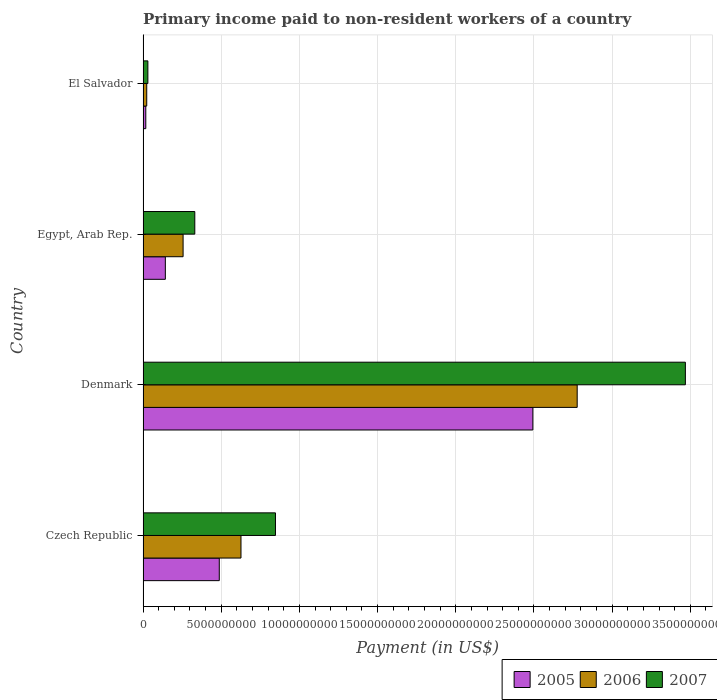How many different coloured bars are there?
Your answer should be very brief. 3. How many bars are there on the 1st tick from the bottom?
Ensure brevity in your answer.  3. What is the label of the 1st group of bars from the top?
Make the answer very short. El Salvador. In how many cases, is the number of bars for a given country not equal to the number of legend labels?
Keep it short and to the point. 0. What is the amount paid to workers in 2005 in El Salvador?
Give a very brief answer. 1.75e+08. Across all countries, what is the maximum amount paid to workers in 2007?
Provide a short and direct response. 3.47e+1. Across all countries, what is the minimum amount paid to workers in 2006?
Your answer should be compact. 2.34e+08. In which country was the amount paid to workers in 2005 maximum?
Ensure brevity in your answer.  Denmark. In which country was the amount paid to workers in 2005 minimum?
Offer a very short reply. El Salvador. What is the total amount paid to workers in 2005 in the graph?
Provide a succinct answer. 3.14e+1. What is the difference between the amount paid to workers in 2005 in Czech Republic and that in Denmark?
Offer a terse response. -2.01e+1. What is the difference between the amount paid to workers in 2005 in El Salvador and the amount paid to workers in 2006 in Czech Republic?
Your response must be concise. -6.09e+09. What is the average amount paid to workers in 2006 per country?
Ensure brevity in your answer.  9.21e+09. What is the difference between the amount paid to workers in 2006 and amount paid to workers in 2007 in El Salvador?
Provide a succinct answer. -7.36e+07. What is the ratio of the amount paid to workers in 2005 in Czech Republic to that in El Salvador?
Provide a succinct answer. 27.9. What is the difference between the highest and the second highest amount paid to workers in 2007?
Ensure brevity in your answer.  2.62e+1. What is the difference between the highest and the lowest amount paid to workers in 2007?
Provide a short and direct response. 3.44e+1. What does the 3rd bar from the bottom in El Salvador represents?
Offer a terse response. 2007. Is it the case that in every country, the sum of the amount paid to workers in 2007 and amount paid to workers in 2006 is greater than the amount paid to workers in 2005?
Offer a very short reply. Yes. How many bars are there?
Offer a terse response. 12. Are all the bars in the graph horizontal?
Keep it short and to the point. Yes. What is the difference between two consecutive major ticks on the X-axis?
Provide a short and direct response. 5.00e+09. Are the values on the major ticks of X-axis written in scientific E-notation?
Provide a succinct answer. No. Does the graph contain grids?
Offer a terse response. Yes. Where does the legend appear in the graph?
Keep it short and to the point. Bottom right. What is the title of the graph?
Offer a very short reply. Primary income paid to non-resident workers of a country. What is the label or title of the X-axis?
Your response must be concise. Payment (in US$). What is the Payment (in US$) of 2005 in Czech Republic?
Keep it short and to the point. 4.87e+09. What is the Payment (in US$) of 2006 in Czech Republic?
Offer a very short reply. 6.26e+09. What is the Payment (in US$) in 2007 in Czech Republic?
Offer a terse response. 8.47e+09. What is the Payment (in US$) of 2005 in Denmark?
Keep it short and to the point. 2.49e+1. What is the Payment (in US$) of 2006 in Denmark?
Keep it short and to the point. 2.78e+1. What is the Payment (in US$) of 2007 in Denmark?
Make the answer very short. 3.47e+1. What is the Payment (in US$) in 2005 in Egypt, Arab Rep.?
Offer a terse response. 1.43e+09. What is the Payment (in US$) of 2006 in Egypt, Arab Rep.?
Make the answer very short. 2.56e+09. What is the Payment (in US$) of 2007 in Egypt, Arab Rep.?
Provide a short and direct response. 3.31e+09. What is the Payment (in US$) in 2005 in El Salvador?
Provide a succinct answer. 1.75e+08. What is the Payment (in US$) in 2006 in El Salvador?
Provide a short and direct response. 2.34e+08. What is the Payment (in US$) in 2007 in El Salvador?
Your answer should be very brief. 3.08e+08. Across all countries, what is the maximum Payment (in US$) in 2005?
Your answer should be compact. 2.49e+1. Across all countries, what is the maximum Payment (in US$) in 2006?
Offer a terse response. 2.78e+1. Across all countries, what is the maximum Payment (in US$) in 2007?
Ensure brevity in your answer.  3.47e+1. Across all countries, what is the minimum Payment (in US$) in 2005?
Offer a very short reply. 1.75e+08. Across all countries, what is the minimum Payment (in US$) in 2006?
Provide a succinct answer. 2.34e+08. Across all countries, what is the minimum Payment (in US$) in 2007?
Provide a short and direct response. 3.08e+08. What is the total Payment (in US$) in 2005 in the graph?
Offer a very short reply. 3.14e+1. What is the total Payment (in US$) of 2006 in the graph?
Your response must be concise. 3.68e+1. What is the total Payment (in US$) of 2007 in the graph?
Provide a short and direct response. 4.68e+1. What is the difference between the Payment (in US$) in 2005 in Czech Republic and that in Denmark?
Give a very brief answer. -2.01e+1. What is the difference between the Payment (in US$) of 2006 in Czech Republic and that in Denmark?
Make the answer very short. -2.15e+1. What is the difference between the Payment (in US$) of 2007 in Czech Republic and that in Denmark?
Offer a very short reply. -2.62e+1. What is the difference between the Payment (in US$) of 2005 in Czech Republic and that in Egypt, Arab Rep.?
Provide a succinct answer. 3.45e+09. What is the difference between the Payment (in US$) in 2006 in Czech Republic and that in Egypt, Arab Rep.?
Offer a terse response. 3.70e+09. What is the difference between the Payment (in US$) in 2007 in Czech Republic and that in Egypt, Arab Rep.?
Offer a terse response. 5.16e+09. What is the difference between the Payment (in US$) in 2005 in Czech Republic and that in El Salvador?
Keep it short and to the point. 4.70e+09. What is the difference between the Payment (in US$) of 2006 in Czech Republic and that in El Salvador?
Make the answer very short. 6.03e+09. What is the difference between the Payment (in US$) in 2007 in Czech Republic and that in El Salvador?
Your response must be concise. 8.16e+09. What is the difference between the Payment (in US$) of 2005 in Denmark and that in Egypt, Arab Rep.?
Give a very brief answer. 2.35e+1. What is the difference between the Payment (in US$) in 2006 in Denmark and that in Egypt, Arab Rep.?
Provide a short and direct response. 2.52e+1. What is the difference between the Payment (in US$) in 2007 in Denmark and that in Egypt, Arab Rep.?
Offer a very short reply. 3.14e+1. What is the difference between the Payment (in US$) in 2005 in Denmark and that in El Salvador?
Offer a terse response. 2.48e+1. What is the difference between the Payment (in US$) in 2006 in Denmark and that in El Salvador?
Give a very brief answer. 2.75e+1. What is the difference between the Payment (in US$) of 2007 in Denmark and that in El Salvador?
Ensure brevity in your answer.  3.44e+1. What is the difference between the Payment (in US$) in 2005 in Egypt, Arab Rep. and that in El Salvador?
Make the answer very short. 1.25e+09. What is the difference between the Payment (in US$) in 2006 in Egypt, Arab Rep. and that in El Salvador?
Provide a short and direct response. 2.33e+09. What is the difference between the Payment (in US$) of 2007 in Egypt, Arab Rep. and that in El Salvador?
Provide a short and direct response. 3.00e+09. What is the difference between the Payment (in US$) in 2005 in Czech Republic and the Payment (in US$) in 2006 in Denmark?
Offer a terse response. -2.29e+1. What is the difference between the Payment (in US$) in 2005 in Czech Republic and the Payment (in US$) in 2007 in Denmark?
Provide a short and direct response. -2.98e+1. What is the difference between the Payment (in US$) of 2006 in Czech Republic and the Payment (in US$) of 2007 in Denmark?
Keep it short and to the point. -2.84e+1. What is the difference between the Payment (in US$) of 2005 in Czech Republic and the Payment (in US$) of 2006 in Egypt, Arab Rep.?
Give a very brief answer. 2.31e+09. What is the difference between the Payment (in US$) in 2005 in Czech Republic and the Payment (in US$) in 2007 in Egypt, Arab Rep.?
Keep it short and to the point. 1.57e+09. What is the difference between the Payment (in US$) in 2006 in Czech Republic and the Payment (in US$) in 2007 in Egypt, Arab Rep.?
Offer a very short reply. 2.95e+09. What is the difference between the Payment (in US$) in 2005 in Czech Republic and the Payment (in US$) in 2006 in El Salvador?
Offer a very short reply. 4.64e+09. What is the difference between the Payment (in US$) of 2005 in Czech Republic and the Payment (in US$) of 2007 in El Salvador?
Your answer should be compact. 4.57e+09. What is the difference between the Payment (in US$) of 2006 in Czech Republic and the Payment (in US$) of 2007 in El Salvador?
Your response must be concise. 5.95e+09. What is the difference between the Payment (in US$) in 2005 in Denmark and the Payment (in US$) in 2006 in Egypt, Arab Rep.?
Provide a succinct answer. 2.24e+1. What is the difference between the Payment (in US$) of 2005 in Denmark and the Payment (in US$) of 2007 in Egypt, Arab Rep.?
Ensure brevity in your answer.  2.16e+1. What is the difference between the Payment (in US$) of 2006 in Denmark and the Payment (in US$) of 2007 in Egypt, Arab Rep.?
Offer a terse response. 2.45e+1. What is the difference between the Payment (in US$) in 2005 in Denmark and the Payment (in US$) in 2006 in El Salvador?
Make the answer very short. 2.47e+1. What is the difference between the Payment (in US$) of 2005 in Denmark and the Payment (in US$) of 2007 in El Salvador?
Provide a short and direct response. 2.46e+1. What is the difference between the Payment (in US$) in 2006 in Denmark and the Payment (in US$) in 2007 in El Salvador?
Ensure brevity in your answer.  2.75e+1. What is the difference between the Payment (in US$) of 2005 in Egypt, Arab Rep. and the Payment (in US$) of 2006 in El Salvador?
Your answer should be very brief. 1.19e+09. What is the difference between the Payment (in US$) of 2005 in Egypt, Arab Rep. and the Payment (in US$) of 2007 in El Salvador?
Keep it short and to the point. 1.12e+09. What is the difference between the Payment (in US$) in 2006 in Egypt, Arab Rep. and the Payment (in US$) in 2007 in El Salvador?
Provide a short and direct response. 2.25e+09. What is the average Payment (in US$) in 2005 per country?
Provide a succinct answer. 7.85e+09. What is the average Payment (in US$) of 2006 per country?
Your answer should be compact. 9.21e+09. What is the average Payment (in US$) in 2007 per country?
Offer a very short reply. 1.17e+1. What is the difference between the Payment (in US$) of 2005 and Payment (in US$) of 2006 in Czech Republic?
Make the answer very short. -1.39e+09. What is the difference between the Payment (in US$) in 2005 and Payment (in US$) in 2007 in Czech Republic?
Provide a succinct answer. -3.59e+09. What is the difference between the Payment (in US$) in 2006 and Payment (in US$) in 2007 in Czech Republic?
Your answer should be very brief. -2.21e+09. What is the difference between the Payment (in US$) in 2005 and Payment (in US$) in 2006 in Denmark?
Offer a very short reply. -2.84e+09. What is the difference between the Payment (in US$) of 2005 and Payment (in US$) of 2007 in Denmark?
Provide a succinct answer. -9.75e+09. What is the difference between the Payment (in US$) of 2006 and Payment (in US$) of 2007 in Denmark?
Provide a succinct answer. -6.92e+09. What is the difference between the Payment (in US$) in 2005 and Payment (in US$) in 2006 in Egypt, Arab Rep.?
Offer a very short reply. -1.14e+09. What is the difference between the Payment (in US$) in 2005 and Payment (in US$) in 2007 in Egypt, Arab Rep.?
Give a very brief answer. -1.88e+09. What is the difference between the Payment (in US$) in 2006 and Payment (in US$) in 2007 in Egypt, Arab Rep.?
Make the answer very short. -7.49e+08. What is the difference between the Payment (in US$) in 2005 and Payment (in US$) in 2006 in El Salvador?
Give a very brief answer. -5.97e+07. What is the difference between the Payment (in US$) in 2005 and Payment (in US$) in 2007 in El Salvador?
Ensure brevity in your answer.  -1.33e+08. What is the difference between the Payment (in US$) in 2006 and Payment (in US$) in 2007 in El Salvador?
Offer a very short reply. -7.36e+07. What is the ratio of the Payment (in US$) in 2005 in Czech Republic to that in Denmark?
Ensure brevity in your answer.  0.2. What is the ratio of the Payment (in US$) in 2006 in Czech Republic to that in Denmark?
Provide a short and direct response. 0.23. What is the ratio of the Payment (in US$) in 2007 in Czech Republic to that in Denmark?
Offer a terse response. 0.24. What is the ratio of the Payment (in US$) of 2005 in Czech Republic to that in Egypt, Arab Rep.?
Your answer should be compact. 3.42. What is the ratio of the Payment (in US$) of 2006 in Czech Republic to that in Egypt, Arab Rep.?
Give a very brief answer. 2.45. What is the ratio of the Payment (in US$) in 2007 in Czech Republic to that in Egypt, Arab Rep.?
Provide a short and direct response. 2.56. What is the ratio of the Payment (in US$) of 2005 in Czech Republic to that in El Salvador?
Your response must be concise. 27.9. What is the ratio of the Payment (in US$) of 2006 in Czech Republic to that in El Salvador?
Offer a very short reply. 26.72. What is the ratio of the Payment (in US$) in 2007 in Czech Republic to that in El Salvador?
Provide a succinct answer. 27.49. What is the ratio of the Payment (in US$) of 2005 in Denmark to that in Egypt, Arab Rep.?
Your answer should be compact. 17.49. What is the ratio of the Payment (in US$) in 2006 in Denmark to that in Egypt, Arab Rep.?
Offer a terse response. 10.84. What is the ratio of the Payment (in US$) of 2007 in Denmark to that in Egypt, Arab Rep.?
Make the answer very short. 10.48. What is the ratio of the Payment (in US$) of 2005 in Denmark to that in El Salvador?
Give a very brief answer. 142.7. What is the ratio of the Payment (in US$) in 2006 in Denmark to that in El Salvador?
Your answer should be very brief. 118.45. What is the ratio of the Payment (in US$) in 2007 in Denmark to that in El Salvador?
Offer a very short reply. 112.6. What is the ratio of the Payment (in US$) of 2005 in Egypt, Arab Rep. to that in El Salvador?
Make the answer very short. 8.16. What is the ratio of the Payment (in US$) in 2006 in Egypt, Arab Rep. to that in El Salvador?
Your answer should be very brief. 10.92. What is the ratio of the Payment (in US$) in 2007 in Egypt, Arab Rep. to that in El Salvador?
Give a very brief answer. 10.74. What is the difference between the highest and the second highest Payment (in US$) of 2005?
Offer a very short reply. 2.01e+1. What is the difference between the highest and the second highest Payment (in US$) in 2006?
Provide a succinct answer. 2.15e+1. What is the difference between the highest and the second highest Payment (in US$) of 2007?
Your answer should be very brief. 2.62e+1. What is the difference between the highest and the lowest Payment (in US$) of 2005?
Your answer should be compact. 2.48e+1. What is the difference between the highest and the lowest Payment (in US$) in 2006?
Your answer should be very brief. 2.75e+1. What is the difference between the highest and the lowest Payment (in US$) of 2007?
Keep it short and to the point. 3.44e+1. 